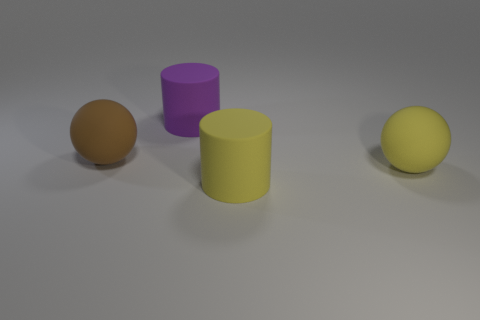Can you tell me about the sizes of the objects in relation to each other? Certainly, the objects present diverse sizes with the purple cylinder and the yellow sphere being of similar size and notably larger than the orange sphere. The yellow cylinder appears the largest among the objects on the left. And what about their arrangement? Is there a pattern? The objects are arranged in a staggered line, giving an impression of depth. There doesn't seem to be a strict pattern, but the positioning allows each object to be clearly visible and presents a sense of balance in the composition. 